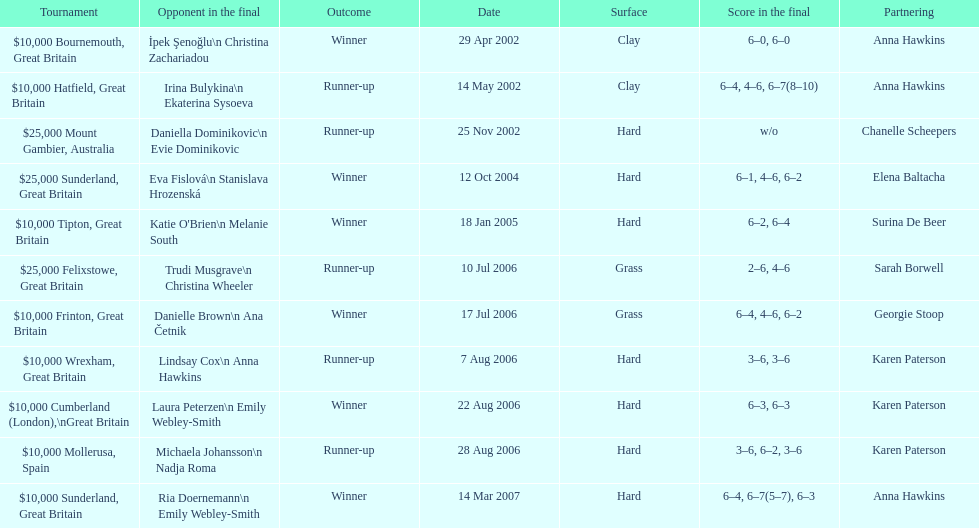How many were played on a hard surface? 7. 